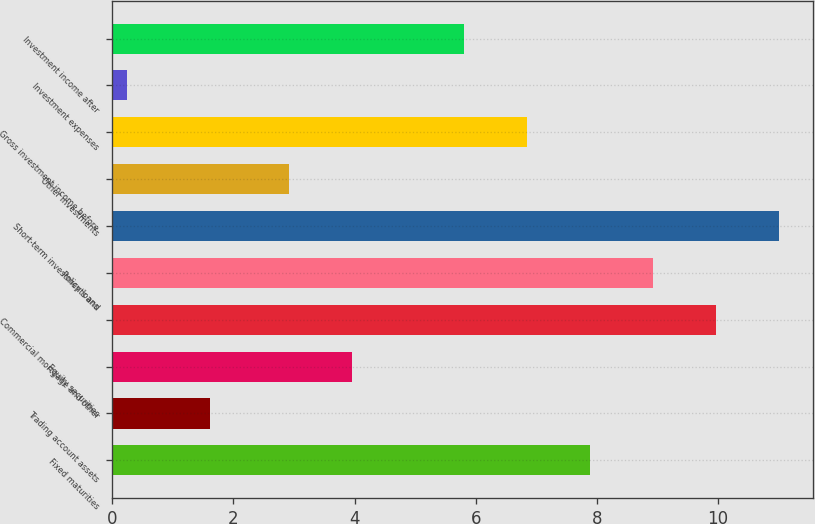Convert chart. <chart><loc_0><loc_0><loc_500><loc_500><bar_chart><fcel>Fixed maturities<fcel>Trading account assets<fcel>Equity securities<fcel>Commercial mortgage and other<fcel>Policy loans<fcel>Short-term investments and<fcel>Other investments<fcel>Gross investment income before<fcel>Investment expenses<fcel>Investment income after<nl><fcel>7.89<fcel>1.62<fcel>3.96<fcel>9.97<fcel>8.93<fcel>11.01<fcel>2.92<fcel>6.85<fcel>0.24<fcel>5.81<nl></chart> 